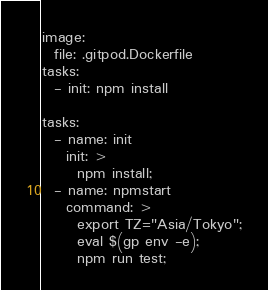<code> <loc_0><loc_0><loc_500><loc_500><_YAML_>image:
  file: .gitpod.Dockerfile
tasks:
  - init: npm install

tasks:
  - name: init
    init: >
      npm install;
  - name: npmstart
    command: >
      export TZ="Asia/Tokyo";
      eval $(gp env -e);
      npm run test;</code> 